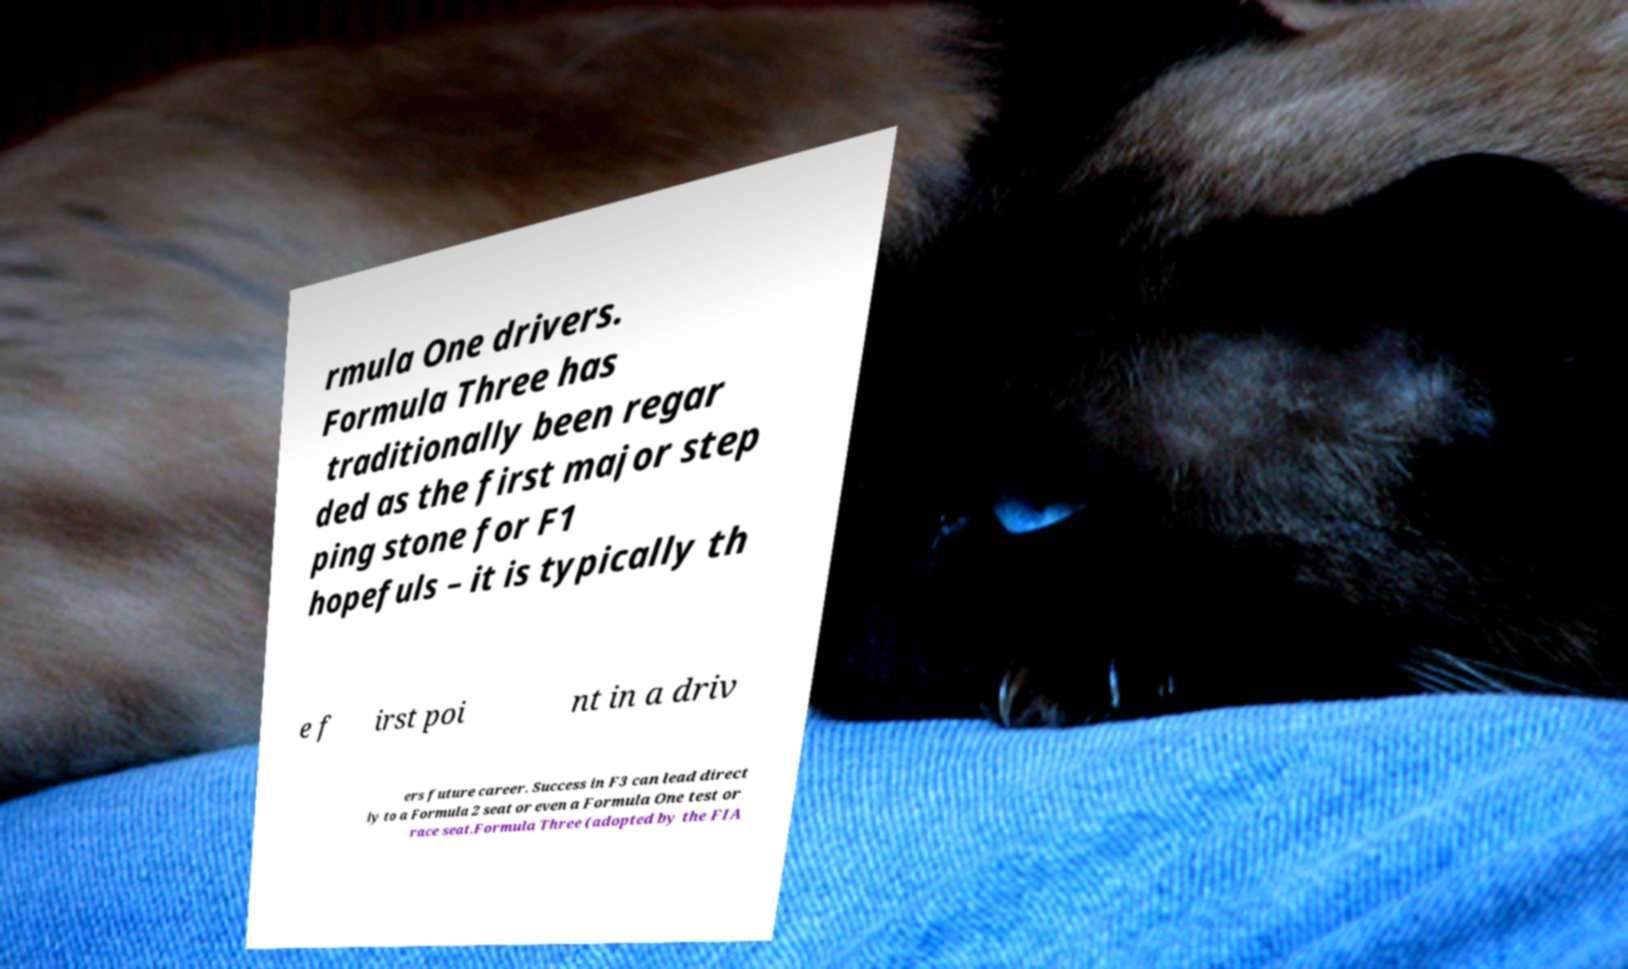Please read and relay the text visible in this image. What does it say? rmula One drivers. Formula Three has traditionally been regar ded as the first major step ping stone for F1 hopefuls – it is typically th e f irst poi nt in a driv ers future career. Success in F3 can lead direct ly to a Formula 2 seat or even a Formula One test or race seat.Formula Three (adopted by the FIA 